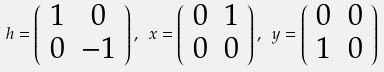Convert formula to latex. <formula><loc_0><loc_0><loc_500><loc_500>h = \left ( \begin{array} { c c } 1 & 0 \\ 0 & - 1 \\ \end{array} \right ) , \ x = \left ( \begin{array} { c c } 0 & 1 \\ 0 & 0 \\ \end{array} \right ) , \ y = \left ( \begin{array} { c c } 0 & 0 \\ 1 & 0 \\ \end{array} \right )</formula> 